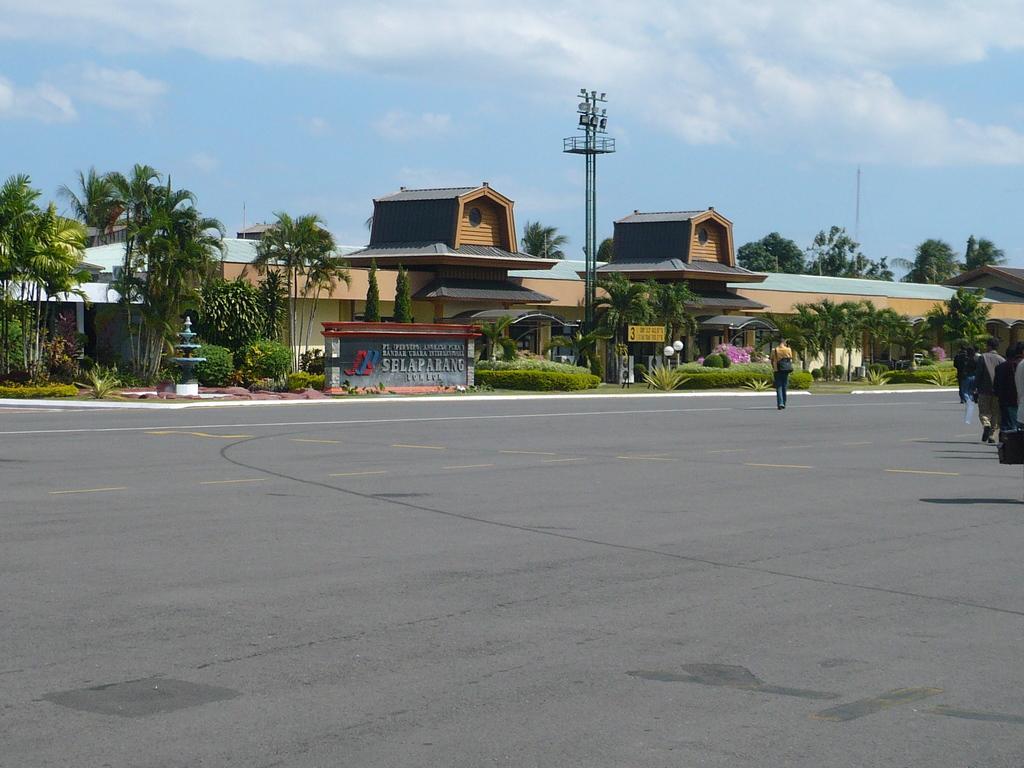Please provide a concise description of this image. This is an outside view. At the bottom, I can see the road. On the right side few people are wearing bags and walking. In the background there is a building and also I can see many plants and trees. Beside the road there is a pole and also there is a wall on which I can see the text. At the top of the image I can see the sky and clouds. 